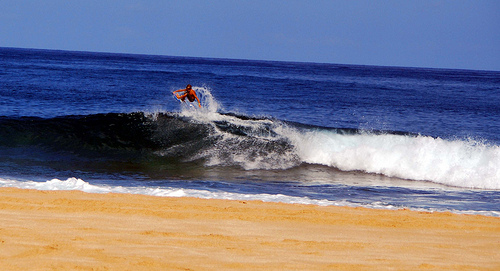Please provide the bounding box coordinate of the region this sentence describes: Blue water in ocean. The vast expanse of blue water can be encompassed within these coordinates: [0.65, 0.30, 0.95, 0.60], capturing the serene azure spread of the ocean's surface. 